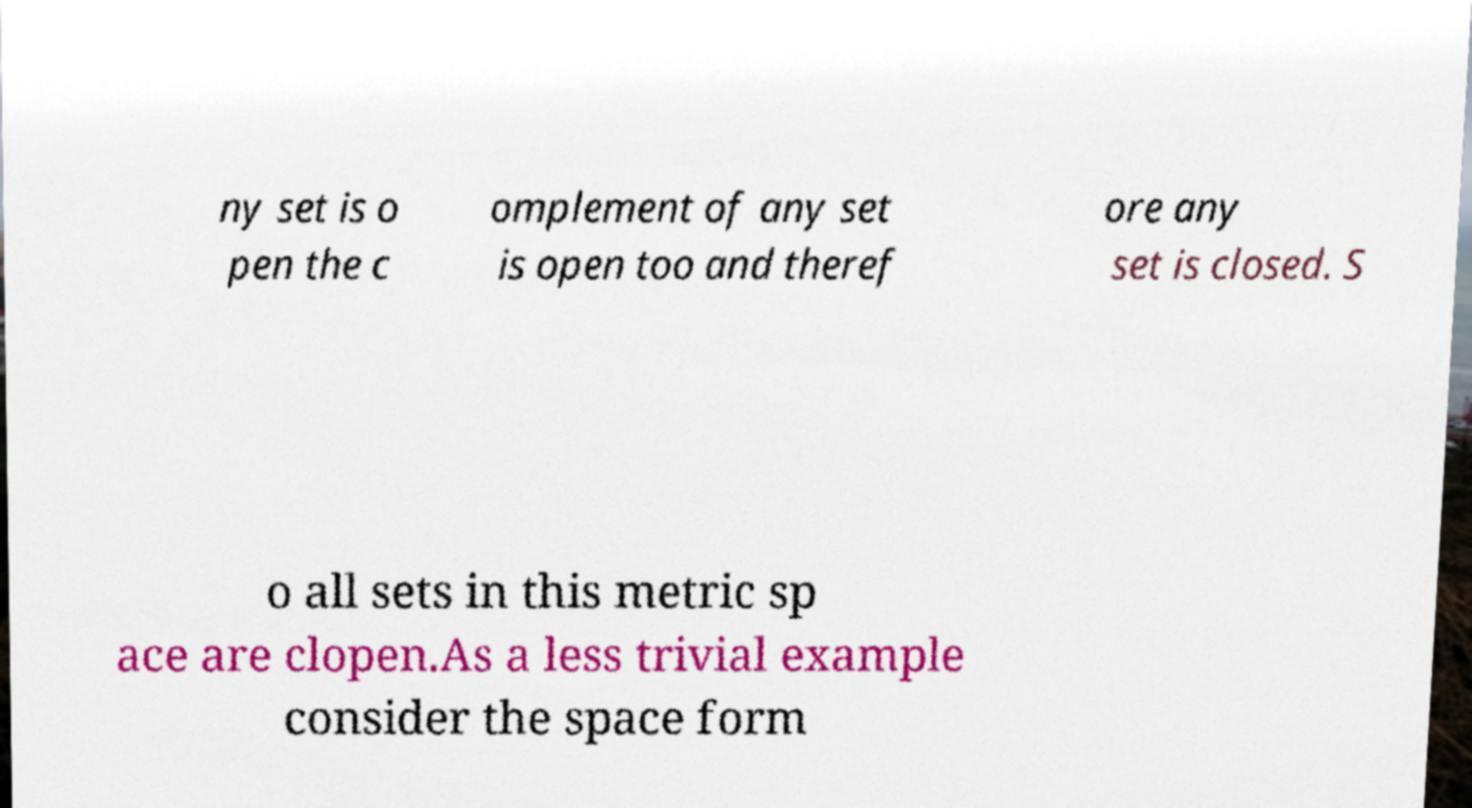Can you read and provide the text displayed in the image?This photo seems to have some interesting text. Can you extract and type it out for me? ny set is o pen the c omplement of any set is open too and theref ore any set is closed. S o all sets in this metric sp ace are clopen.As a less trivial example consider the space form 